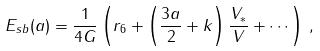Convert formula to latex. <formula><loc_0><loc_0><loc_500><loc_500>E _ { s b } ( a ) = \frac { 1 } { 4 G } \left ( r _ { 6 } + \left ( \frac { 3 a } { 2 } + k \right ) \frac { V _ { * } } { V } + \cdots \right ) \, ,</formula> 